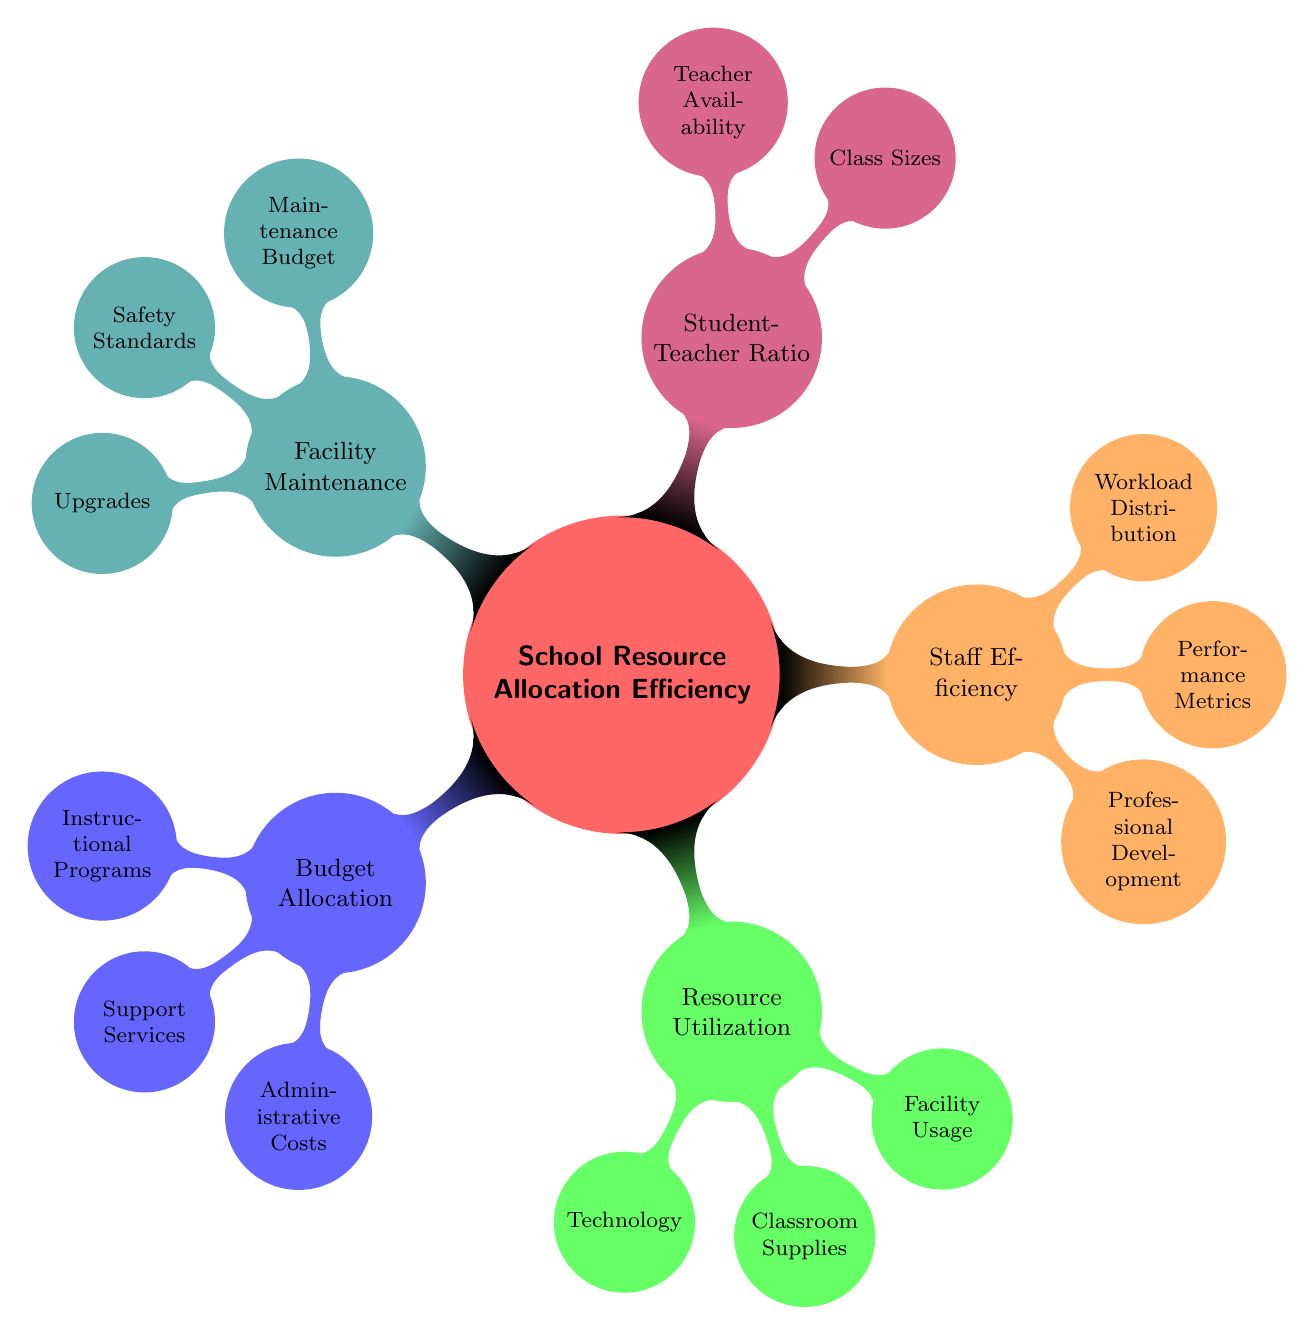What are the two main categories under Budget Allocation? The Budget Allocation node has three sub-nodes: Instructional Programs, Support Services, and Administrative Costs. The question asks for two of them, so we can pick any two.
Answer: Instructional Programs, Support Services How many nodes are under Resource Utilization? The Resource Utilization category has three sub-nodes listed under it: Technology, Classroom Supplies, and Facility Usage, making a total of three nodes.
Answer: 3 What is the main focus of Staff Efficiency? The Staff Efficiency category deals with aspects such as Professional Development, Performance Metrics, and Workload Distribution, indicating the focus is on improving teacher capabilities and productivity.
Answer: Teacher capabilities and productivity Which category includes Safety Standards? Safety Standards is a sub-node that comes under Facility Maintenance, which covers aspects related to keeping school facilities safe and functional.
Answer: Facility Maintenance What is the relationship between Class Sizes and Student-Teacher Ratio? Class Sizes is a sub-node of Student-Teacher Ratio, indicating that it contributes to or is a part of measuring the Student-Teacher Ratio.
Answer: Class Sizes is a sub-node How does the Professional Development relate to performance in the Staff Efficiency section? Professional Development aims to enhance teacher skills, which directly impacts the Performance Metrics sub-node since well-trained teachers likely achieve better student outcomes, linking both concepts in improving educational quality.
Answer: Enhances teacher skills, impacts performance metrics What are the components included in Facility Maintenance? The Facility Maintenance category includes three components: Maintenance Budget, Safety Standards, and Upgrades, which collectively contribute to maintaining and improving the school facilities.
Answer: Maintenance Budget, Safety Standards, Upgrades How many edges are there connecting Budget Allocation to its sub-nodes? Budget Allocation connects directly to three sub-nodes, which each represent a single edge, resulting in a total of three edges connected to its direct sub-nodes.
Answer: 3 What does the term Workload Distribution refer to in Staff Efficiency? Workload Distribution pertains to how teaching hours and administrative duties are allocated among staff members, emphasizing efficiency in staff utilization and workload management.
Answer: Allocation of teaching hours and duties 